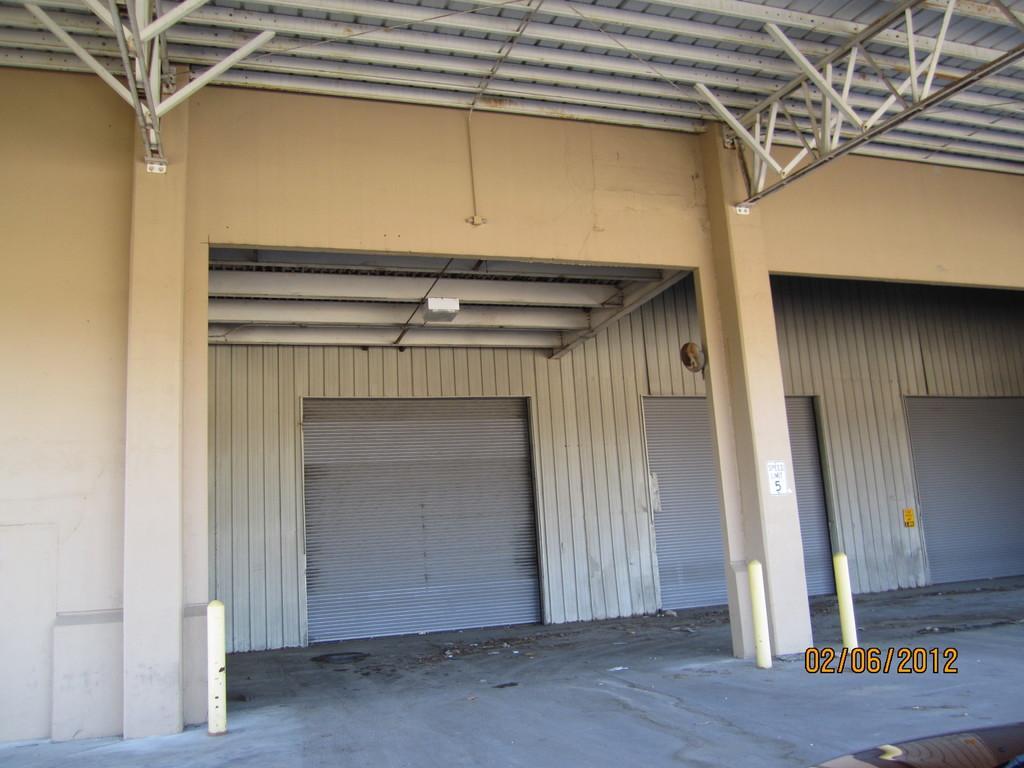Please provide a concise description of this image. We can see pillars and wall. Top we can see rods. Bottom right side of the image we can see date. 